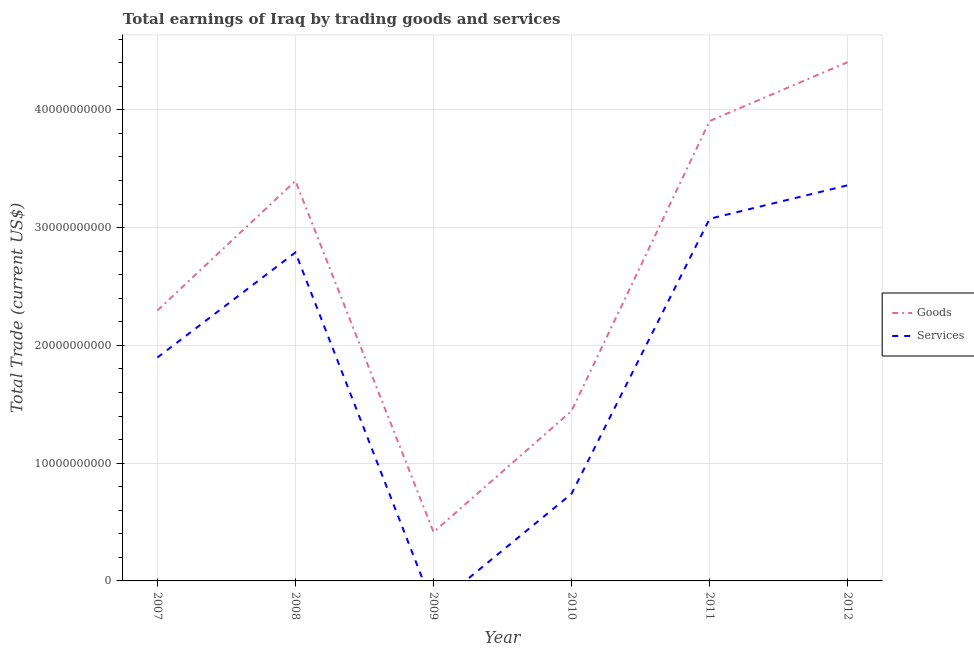How many different coloured lines are there?
Offer a terse response. 2. Does the line corresponding to amount earned by trading services intersect with the line corresponding to amount earned by trading goods?
Offer a very short reply. No. Is the number of lines equal to the number of legend labels?
Keep it short and to the point. No. What is the amount earned by trading services in 2010?
Ensure brevity in your answer.  7.40e+09. Across all years, what is the maximum amount earned by trading services?
Your answer should be compact. 3.36e+1. Across all years, what is the minimum amount earned by trading services?
Offer a very short reply. 0. What is the total amount earned by trading services in the graph?
Provide a succinct answer. 1.19e+11. What is the difference between the amount earned by trading goods in 2011 and that in 2012?
Provide a succinct answer. -5.00e+09. What is the difference between the amount earned by trading services in 2009 and the amount earned by trading goods in 2011?
Offer a very short reply. -3.91e+1. What is the average amount earned by trading services per year?
Offer a terse response. 1.98e+1. In the year 2010, what is the difference between the amount earned by trading goods and amount earned by trading services?
Your response must be concise. 7.03e+09. In how many years, is the amount earned by trading services greater than 2000000000 US$?
Ensure brevity in your answer.  5. What is the ratio of the amount earned by trading services in 2007 to that in 2010?
Offer a terse response. 2.56. Is the amount earned by trading goods in 2008 less than that in 2010?
Give a very brief answer. No. Is the difference between the amount earned by trading goods in 2010 and 2011 greater than the difference between the amount earned by trading services in 2010 and 2011?
Give a very brief answer. No. What is the difference between the highest and the second highest amount earned by trading goods?
Offer a very short reply. 5.00e+09. What is the difference between the highest and the lowest amount earned by trading goods?
Give a very brief answer. 3.99e+1. In how many years, is the amount earned by trading services greater than the average amount earned by trading services taken over all years?
Give a very brief answer. 3. Is the sum of the amount earned by trading services in 2010 and 2011 greater than the maximum amount earned by trading goods across all years?
Make the answer very short. No. Is the amount earned by trading services strictly greater than the amount earned by trading goods over the years?
Offer a terse response. No. Is the amount earned by trading services strictly less than the amount earned by trading goods over the years?
Give a very brief answer. Yes. What is the difference between two consecutive major ticks on the Y-axis?
Ensure brevity in your answer.  1.00e+1. Are the values on the major ticks of Y-axis written in scientific E-notation?
Provide a succinct answer. No. What is the title of the graph?
Your answer should be very brief. Total earnings of Iraq by trading goods and services. What is the label or title of the X-axis?
Provide a short and direct response. Year. What is the label or title of the Y-axis?
Give a very brief answer. Total Trade (current US$). What is the Total Trade (current US$) in Goods in 2007?
Provide a succinct answer. 2.30e+1. What is the Total Trade (current US$) of Services in 2007?
Your response must be concise. 1.90e+1. What is the Total Trade (current US$) in Goods in 2008?
Give a very brief answer. 3.40e+1. What is the Total Trade (current US$) of Services in 2008?
Ensure brevity in your answer.  2.79e+1. What is the Total Trade (current US$) in Goods in 2009?
Offer a terse response. 4.14e+09. What is the Total Trade (current US$) of Services in 2009?
Your answer should be compact. 0. What is the Total Trade (current US$) of Goods in 2010?
Your answer should be very brief. 1.44e+1. What is the Total Trade (current US$) of Services in 2010?
Provide a succinct answer. 7.40e+09. What is the Total Trade (current US$) in Goods in 2011?
Ensure brevity in your answer.  3.91e+1. What is the Total Trade (current US$) in Services in 2011?
Your response must be concise. 3.07e+1. What is the Total Trade (current US$) in Goods in 2012?
Make the answer very short. 4.41e+1. What is the Total Trade (current US$) in Services in 2012?
Ensure brevity in your answer.  3.36e+1. Across all years, what is the maximum Total Trade (current US$) in Goods?
Your answer should be compact. 4.41e+1. Across all years, what is the maximum Total Trade (current US$) in Services?
Give a very brief answer. 3.36e+1. Across all years, what is the minimum Total Trade (current US$) in Goods?
Offer a terse response. 4.14e+09. Across all years, what is the minimum Total Trade (current US$) of Services?
Keep it short and to the point. 0. What is the total Total Trade (current US$) of Goods in the graph?
Your response must be concise. 1.59e+11. What is the total Total Trade (current US$) in Services in the graph?
Provide a short and direct response. 1.19e+11. What is the difference between the Total Trade (current US$) in Goods in 2007 and that in 2008?
Your response must be concise. -1.10e+1. What is the difference between the Total Trade (current US$) in Services in 2007 and that in 2008?
Ensure brevity in your answer.  -8.92e+09. What is the difference between the Total Trade (current US$) in Goods in 2007 and that in 2009?
Your answer should be very brief. 1.88e+1. What is the difference between the Total Trade (current US$) in Goods in 2007 and that in 2010?
Your answer should be compact. 8.53e+09. What is the difference between the Total Trade (current US$) of Services in 2007 and that in 2010?
Make the answer very short. 1.16e+1. What is the difference between the Total Trade (current US$) of Goods in 2007 and that in 2011?
Ensure brevity in your answer.  -1.61e+1. What is the difference between the Total Trade (current US$) in Services in 2007 and that in 2011?
Provide a succinct answer. -1.18e+1. What is the difference between the Total Trade (current US$) in Goods in 2007 and that in 2012?
Offer a very short reply. -2.11e+1. What is the difference between the Total Trade (current US$) of Services in 2007 and that in 2012?
Ensure brevity in your answer.  -1.46e+1. What is the difference between the Total Trade (current US$) in Goods in 2008 and that in 2009?
Provide a succinct answer. 2.98e+1. What is the difference between the Total Trade (current US$) of Goods in 2008 and that in 2010?
Offer a terse response. 1.95e+1. What is the difference between the Total Trade (current US$) in Services in 2008 and that in 2010?
Your answer should be very brief. 2.05e+1. What is the difference between the Total Trade (current US$) of Goods in 2008 and that in 2011?
Offer a very short reply. -5.08e+09. What is the difference between the Total Trade (current US$) in Services in 2008 and that in 2011?
Keep it short and to the point. -2.86e+09. What is the difference between the Total Trade (current US$) of Goods in 2008 and that in 2012?
Offer a terse response. -1.01e+1. What is the difference between the Total Trade (current US$) in Services in 2008 and that in 2012?
Make the answer very short. -5.70e+09. What is the difference between the Total Trade (current US$) in Goods in 2009 and that in 2010?
Your response must be concise. -1.03e+1. What is the difference between the Total Trade (current US$) in Goods in 2009 and that in 2011?
Provide a short and direct response. -3.49e+1. What is the difference between the Total Trade (current US$) in Goods in 2009 and that in 2012?
Make the answer very short. -3.99e+1. What is the difference between the Total Trade (current US$) in Goods in 2010 and that in 2011?
Provide a short and direct response. -2.46e+1. What is the difference between the Total Trade (current US$) of Services in 2010 and that in 2011?
Offer a very short reply. -2.33e+1. What is the difference between the Total Trade (current US$) of Goods in 2010 and that in 2012?
Offer a terse response. -2.96e+1. What is the difference between the Total Trade (current US$) of Services in 2010 and that in 2012?
Ensure brevity in your answer.  -2.62e+1. What is the difference between the Total Trade (current US$) in Goods in 2011 and that in 2012?
Make the answer very short. -5.00e+09. What is the difference between the Total Trade (current US$) of Services in 2011 and that in 2012?
Provide a short and direct response. -2.84e+09. What is the difference between the Total Trade (current US$) in Goods in 2007 and the Total Trade (current US$) in Services in 2008?
Your answer should be very brief. -4.93e+09. What is the difference between the Total Trade (current US$) of Goods in 2007 and the Total Trade (current US$) of Services in 2010?
Make the answer very short. 1.56e+1. What is the difference between the Total Trade (current US$) of Goods in 2007 and the Total Trade (current US$) of Services in 2011?
Your answer should be very brief. -7.78e+09. What is the difference between the Total Trade (current US$) in Goods in 2007 and the Total Trade (current US$) in Services in 2012?
Your answer should be compact. -1.06e+1. What is the difference between the Total Trade (current US$) of Goods in 2008 and the Total Trade (current US$) of Services in 2010?
Offer a terse response. 2.66e+1. What is the difference between the Total Trade (current US$) of Goods in 2008 and the Total Trade (current US$) of Services in 2011?
Your response must be concise. 3.22e+09. What is the difference between the Total Trade (current US$) in Goods in 2008 and the Total Trade (current US$) in Services in 2012?
Give a very brief answer. 3.73e+08. What is the difference between the Total Trade (current US$) of Goods in 2009 and the Total Trade (current US$) of Services in 2010?
Ensure brevity in your answer.  -3.26e+09. What is the difference between the Total Trade (current US$) in Goods in 2009 and the Total Trade (current US$) in Services in 2011?
Offer a very short reply. -2.66e+1. What is the difference between the Total Trade (current US$) of Goods in 2009 and the Total Trade (current US$) of Services in 2012?
Your response must be concise. -2.94e+1. What is the difference between the Total Trade (current US$) of Goods in 2010 and the Total Trade (current US$) of Services in 2011?
Offer a very short reply. -1.63e+1. What is the difference between the Total Trade (current US$) in Goods in 2010 and the Total Trade (current US$) in Services in 2012?
Make the answer very short. -1.92e+1. What is the difference between the Total Trade (current US$) in Goods in 2011 and the Total Trade (current US$) in Services in 2012?
Make the answer very short. 5.46e+09. What is the average Total Trade (current US$) of Goods per year?
Provide a short and direct response. 2.64e+1. What is the average Total Trade (current US$) of Services per year?
Offer a very short reply. 1.98e+1. In the year 2007, what is the difference between the Total Trade (current US$) of Goods and Total Trade (current US$) of Services?
Give a very brief answer. 4.00e+09. In the year 2008, what is the difference between the Total Trade (current US$) in Goods and Total Trade (current US$) in Services?
Your answer should be very brief. 6.08e+09. In the year 2010, what is the difference between the Total Trade (current US$) in Goods and Total Trade (current US$) in Services?
Your response must be concise. 7.03e+09. In the year 2011, what is the difference between the Total Trade (current US$) of Goods and Total Trade (current US$) of Services?
Keep it short and to the point. 8.30e+09. In the year 2012, what is the difference between the Total Trade (current US$) in Goods and Total Trade (current US$) in Services?
Keep it short and to the point. 1.05e+1. What is the ratio of the Total Trade (current US$) of Goods in 2007 to that in 2008?
Keep it short and to the point. 0.68. What is the ratio of the Total Trade (current US$) in Services in 2007 to that in 2008?
Keep it short and to the point. 0.68. What is the ratio of the Total Trade (current US$) in Goods in 2007 to that in 2009?
Keep it short and to the point. 5.54. What is the ratio of the Total Trade (current US$) in Goods in 2007 to that in 2010?
Your answer should be compact. 1.59. What is the ratio of the Total Trade (current US$) in Services in 2007 to that in 2010?
Your answer should be compact. 2.56. What is the ratio of the Total Trade (current US$) of Goods in 2007 to that in 2011?
Give a very brief answer. 0.59. What is the ratio of the Total Trade (current US$) in Services in 2007 to that in 2011?
Your answer should be compact. 0.62. What is the ratio of the Total Trade (current US$) of Goods in 2007 to that in 2012?
Keep it short and to the point. 0.52. What is the ratio of the Total Trade (current US$) of Services in 2007 to that in 2012?
Provide a succinct answer. 0.56. What is the ratio of the Total Trade (current US$) in Goods in 2008 to that in 2009?
Your answer should be very brief. 8.2. What is the ratio of the Total Trade (current US$) of Goods in 2008 to that in 2010?
Offer a terse response. 2.35. What is the ratio of the Total Trade (current US$) in Services in 2008 to that in 2010?
Offer a very short reply. 3.77. What is the ratio of the Total Trade (current US$) in Goods in 2008 to that in 2011?
Give a very brief answer. 0.87. What is the ratio of the Total Trade (current US$) of Services in 2008 to that in 2011?
Provide a short and direct response. 0.91. What is the ratio of the Total Trade (current US$) of Goods in 2008 to that in 2012?
Offer a terse response. 0.77. What is the ratio of the Total Trade (current US$) in Services in 2008 to that in 2012?
Ensure brevity in your answer.  0.83. What is the ratio of the Total Trade (current US$) in Goods in 2009 to that in 2010?
Give a very brief answer. 0.29. What is the ratio of the Total Trade (current US$) in Goods in 2009 to that in 2011?
Offer a terse response. 0.11. What is the ratio of the Total Trade (current US$) in Goods in 2009 to that in 2012?
Keep it short and to the point. 0.09. What is the ratio of the Total Trade (current US$) in Goods in 2010 to that in 2011?
Give a very brief answer. 0.37. What is the ratio of the Total Trade (current US$) of Services in 2010 to that in 2011?
Make the answer very short. 0.24. What is the ratio of the Total Trade (current US$) in Goods in 2010 to that in 2012?
Your response must be concise. 0.33. What is the ratio of the Total Trade (current US$) of Services in 2010 to that in 2012?
Provide a succinct answer. 0.22. What is the ratio of the Total Trade (current US$) of Goods in 2011 to that in 2012?
Ensure brevity in your answer.  0.89. What is the ratio of the Total Trade (current US$) in Services in 2011 to that in 2012?
Offer a very short reply. 0.92. What is the difference between the highest and the second highest Total Trade (current US$) in Goods?
Keep it short and to the point. 5.00e+09. What is the difference between the highest and the second highest Total Trade (current US$) of Services?
Provide a succinct answer. 2.84e+09. What is the difference between the highest and the lowest Total Trade (current US$) in Goods?
Your answer should be very brief. 3.99e+1. What is the difference between the highest and the lowest Total Trade (current US$) in Services?
Offer a very short reply. 3.36e+1. 